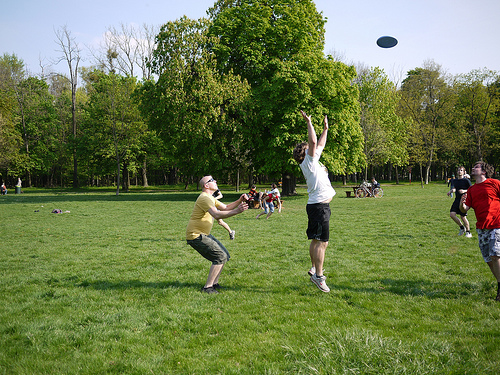Which direction is the man that is to the right of the bench looking at? The man that is to the right of the bench is looking up, possibly following the frisbee in the air. 